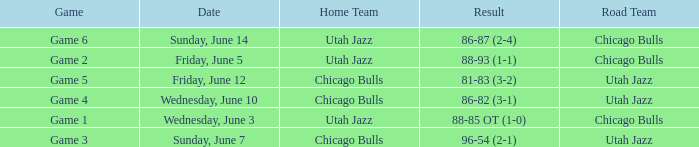Result of 86-87 (2-4) involves what home team? Utah Jazz. 